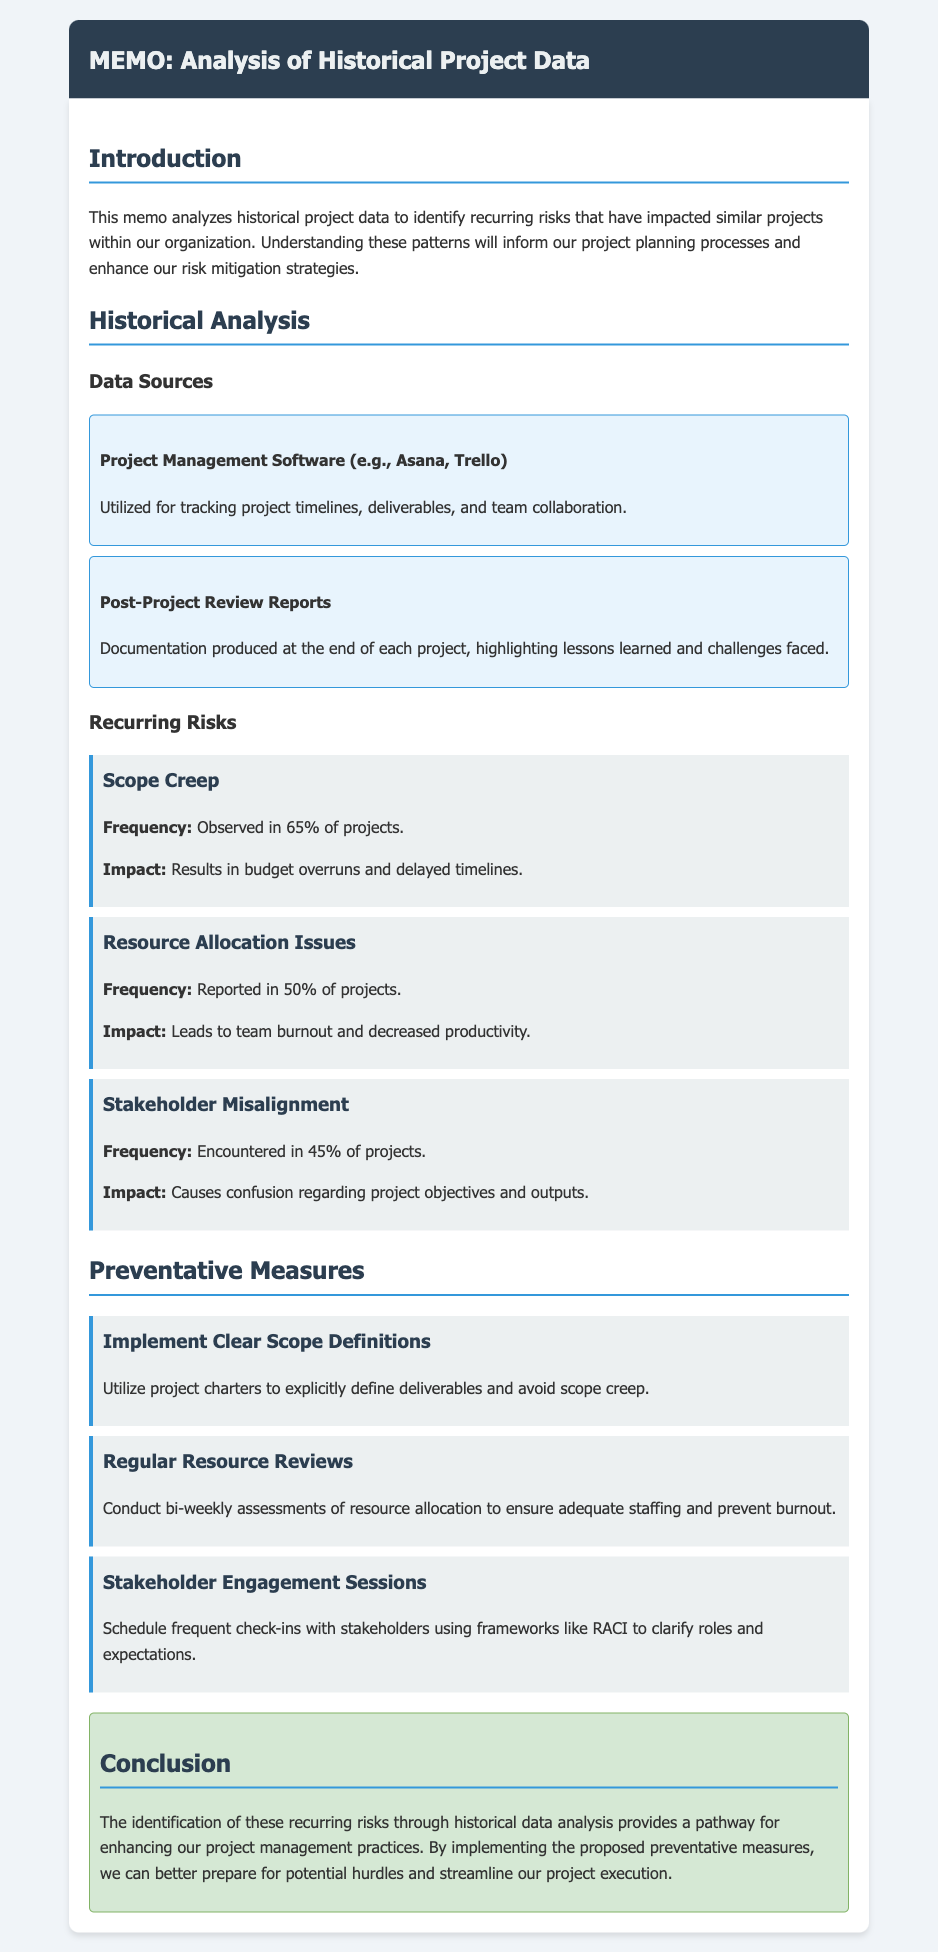What is the most frequent risk identified in projects? The document states that scope creep is observed in 65% of projects, making it the most frequent risk.
Answer: Scope Creep How often are resource allocation issues reported? The document mentions that resource allocation issues are reported in 50% of projects.
Answer: 50% What measure is proposed to avoid scope creep? The document suggests utilizing project charters to explicitly define deliverables as a preventative measure against scope creep.
Answer: Clear Scope Definitions How frequently should resource reviews be conducted? The document states that bi-weekly assessments of resource allocation should be conducted.
Answer: Bi-weekly What is the impact of stakeholder misalignment? According to the document, stakeholder misalignment causes confusion regarding project objectives and outputs.
Answer: Confusion What percentage of projects encountered stakeholder misalignment? The document indicates that stakeholder misalignment was encountered in 45% of projects.
Answer: 45% What is one of the data sources used for the analysis? The document lists project management software, such as Asana and Trello, as a data source.
Answer: Project Management Software What is the main purpose of analyzing historical project data? The document specifies that the main purpose is to identify recurring risks that have impacted similar projects.
Answer: Identify recurring risks 